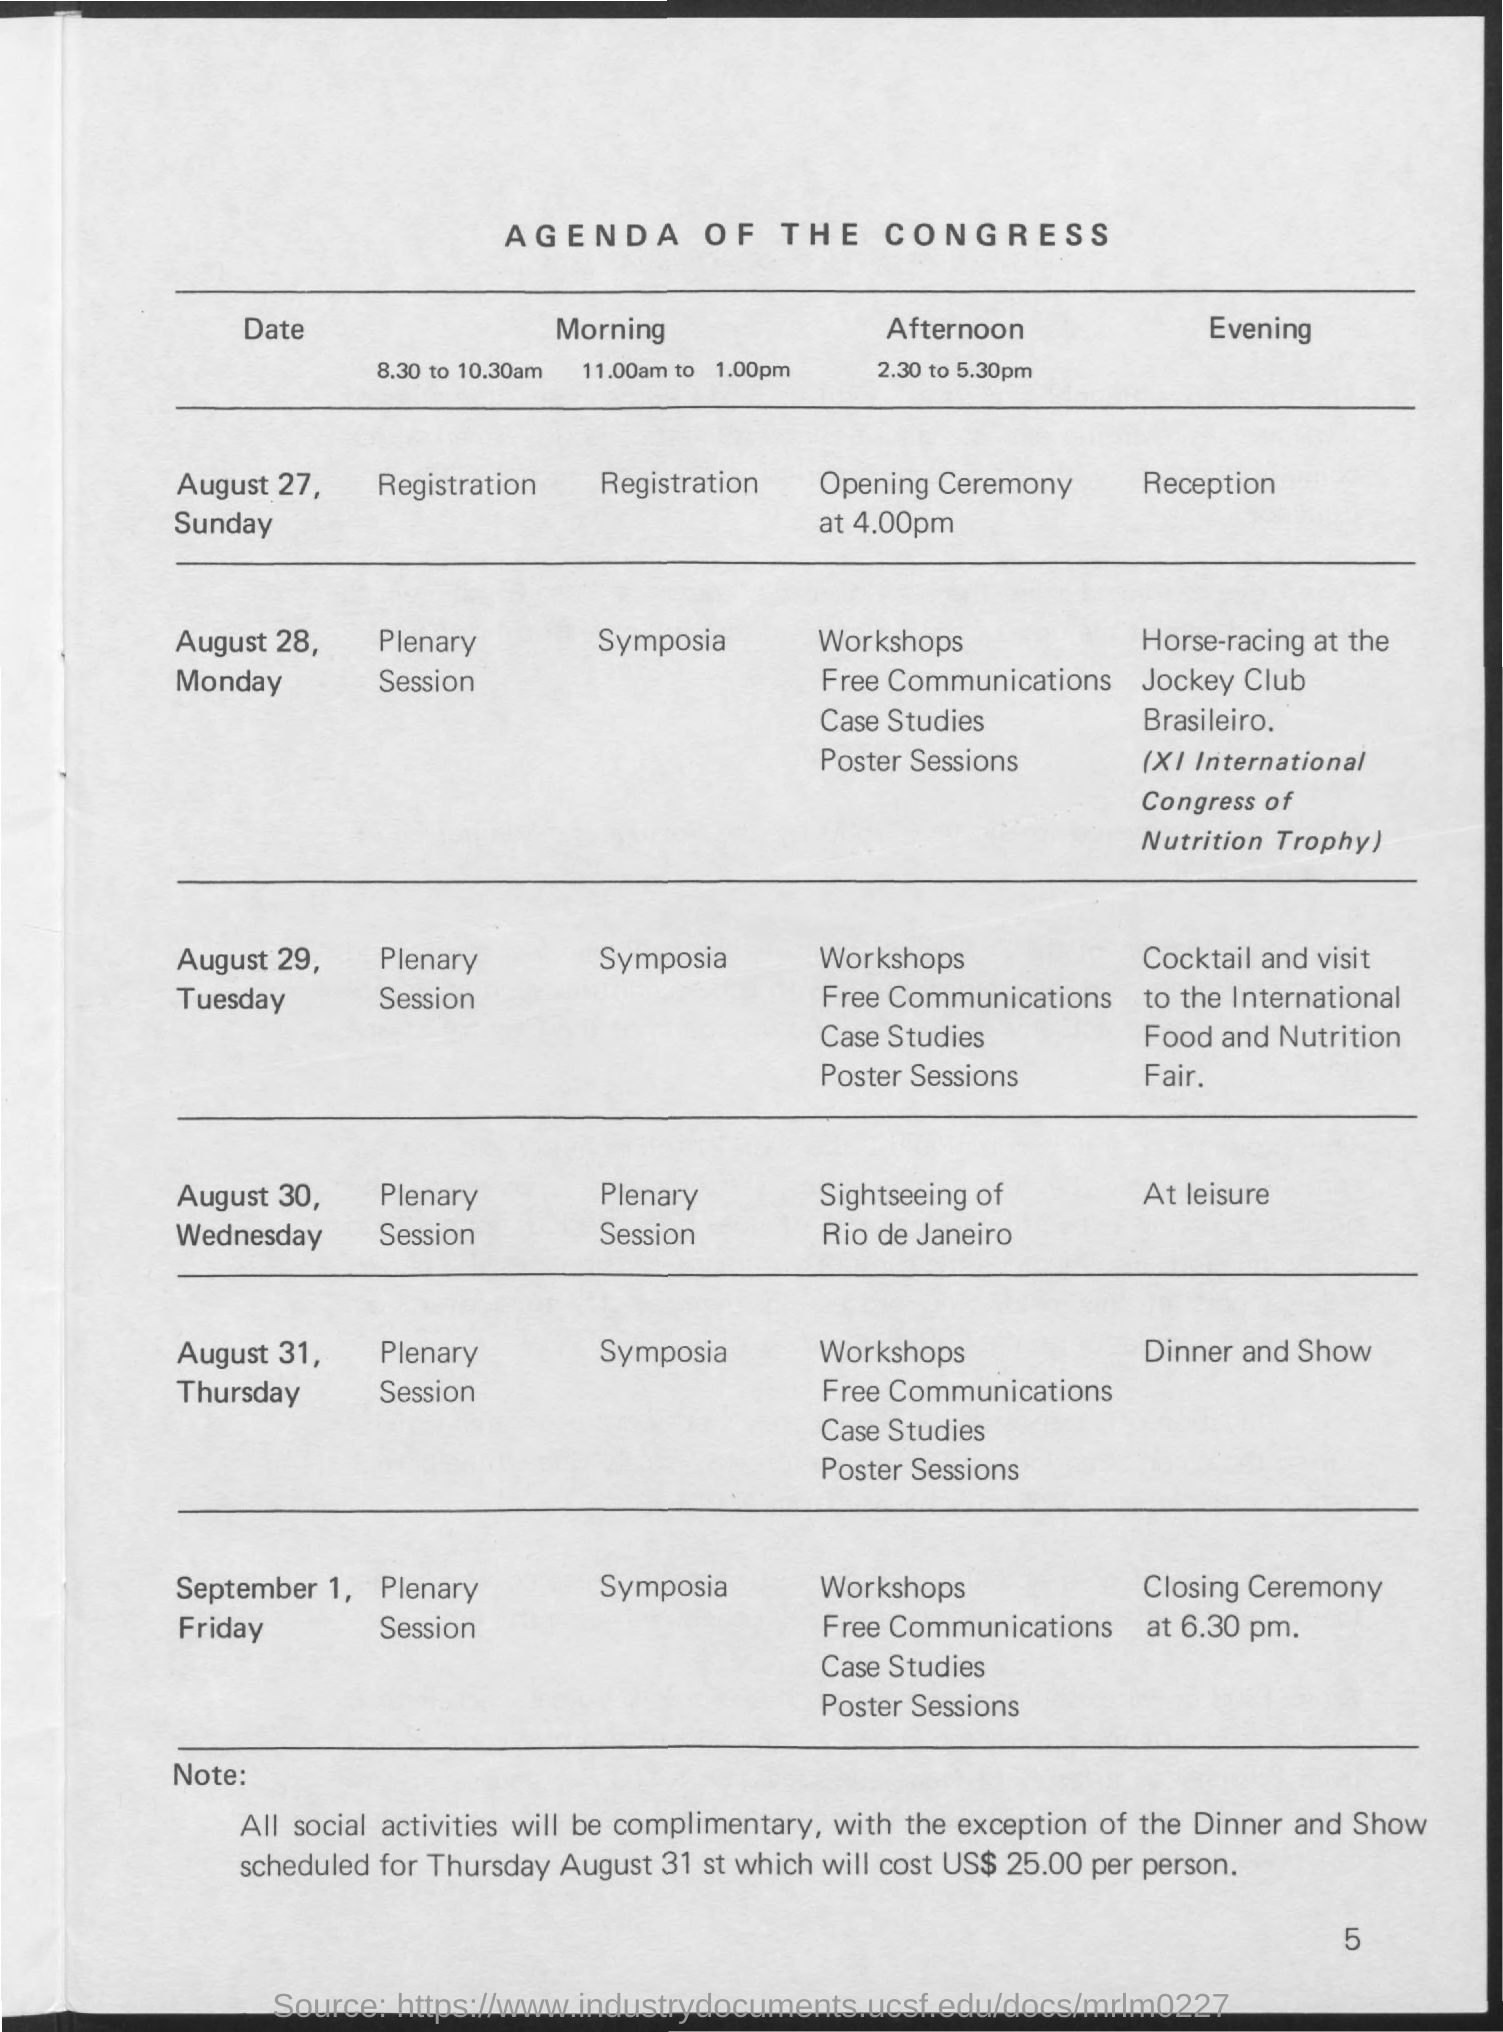What is the title of the document?
Keep it short and to the point. AGENDA OF THE CONGRESS. 